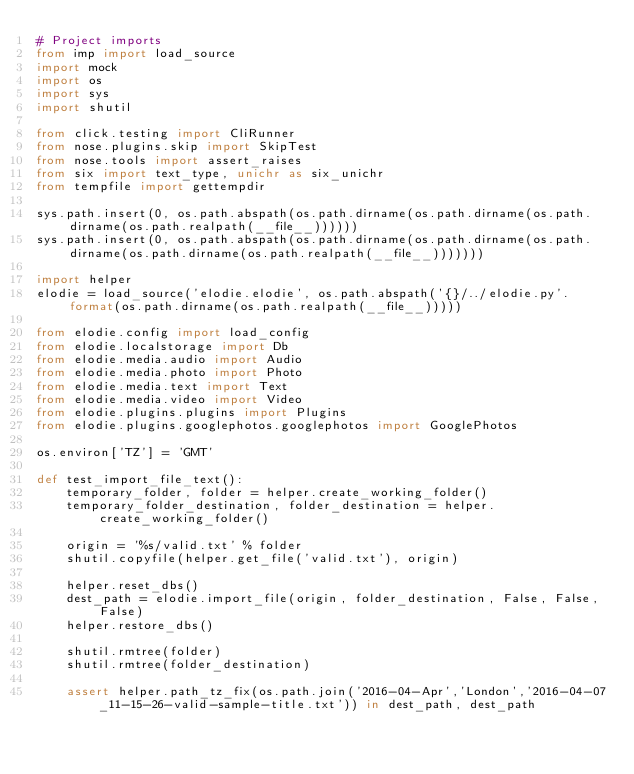Convert code to text. <code><loc_0><loc_0><loc_500><loc_500><_Python_># Project imports
from imp import load_source
import mock
import os
import sys
import shutil

from click.testing import CliRunner
from nose.plugins.skip import SkipTest
from nose.tools import assert_raises
from six import text_type, unichr as six_unichr
from tempfile import gettempdir

sys.path.insert(0, os.path.abspath(os.path.dirname(os.path.dirname(os.path.dirname(os.path.realpath(__file__))))))
sys.path.insert(0, os.path.abspath(os.path.dirname(os.path.dirname(os.path.dirname(os.path.dirname(os.path.realpath(__file__)))))))

import helper
elodie = load_source('elodie.elodie', os.path.abspath('{}/../elodie.py'.format(os.path.dirname(os.path.realpath(__file__)))))

from elodie.config import load_config
from elodie.localstorage import Db
from elodie.media.audio import Audio
from elodie.media.photo import Photo
from elodie.media.text import Text
from elodie.media.video import Video
from elodie.plugins.plugins import Plugins
from elodie.plugins.googlephotos.googlephotos import GooglePhotos

os.environ['TZ'] = 'GMT'

def test_import_file_text():
    temporary_folder, folder = helper.create_working_folder()
    temporary_folder_destination, folder_destination = helper.create_working_folder()

    origin = '%s/valid.txt' % folder
    shutil.copyfile(helper.get_file('valid.txt'), origin)

    helper.reset_dbs()
    dest_path = elodie.import_file(origin, folder_destination, False, False, False)
    helper.restore_dbs()

    shutil.rmtree(folder)
    shutil.rmtree(folder_destination)

    assert helper.path_tz_fix(os.path.join('2016-04-Apr','London','2016-04-07_11-15-26-valid-sample-title.txt')) in dest_path, dest_path
</code> 